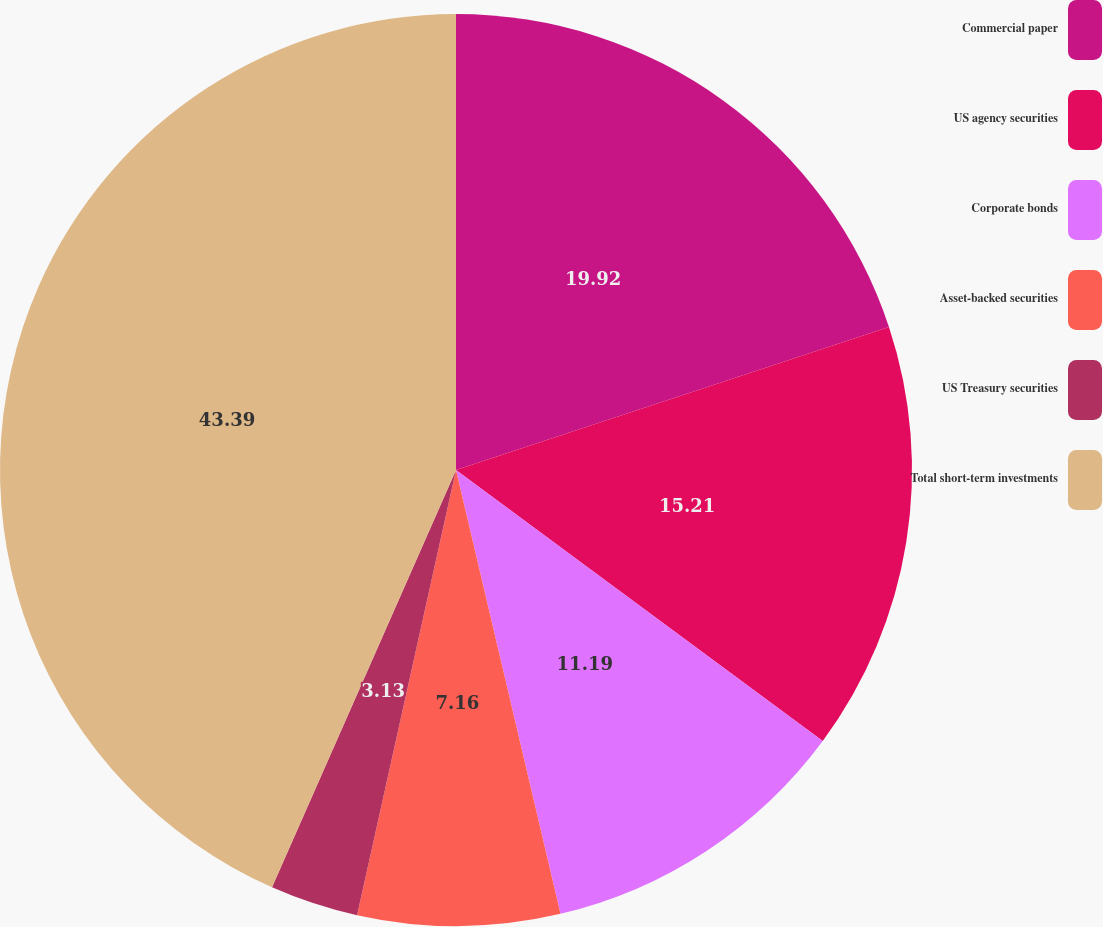Convert chart to OTSL. <chart><loc_0><loc_0><loc_500><loc_500><pie_chart><fcel>Commercial paper<fcel>US agency securities<fcel>Corporate bonds<fcel>Asset-backed securities<fcel>US Treasury securities<fcel>Total short-term investments<nl><fcel>19.92%<fcel>15.21%<fcel>11.19%<fcel>7.16%<fcel>3.13%<fcel>43.39%<nl></chart> 